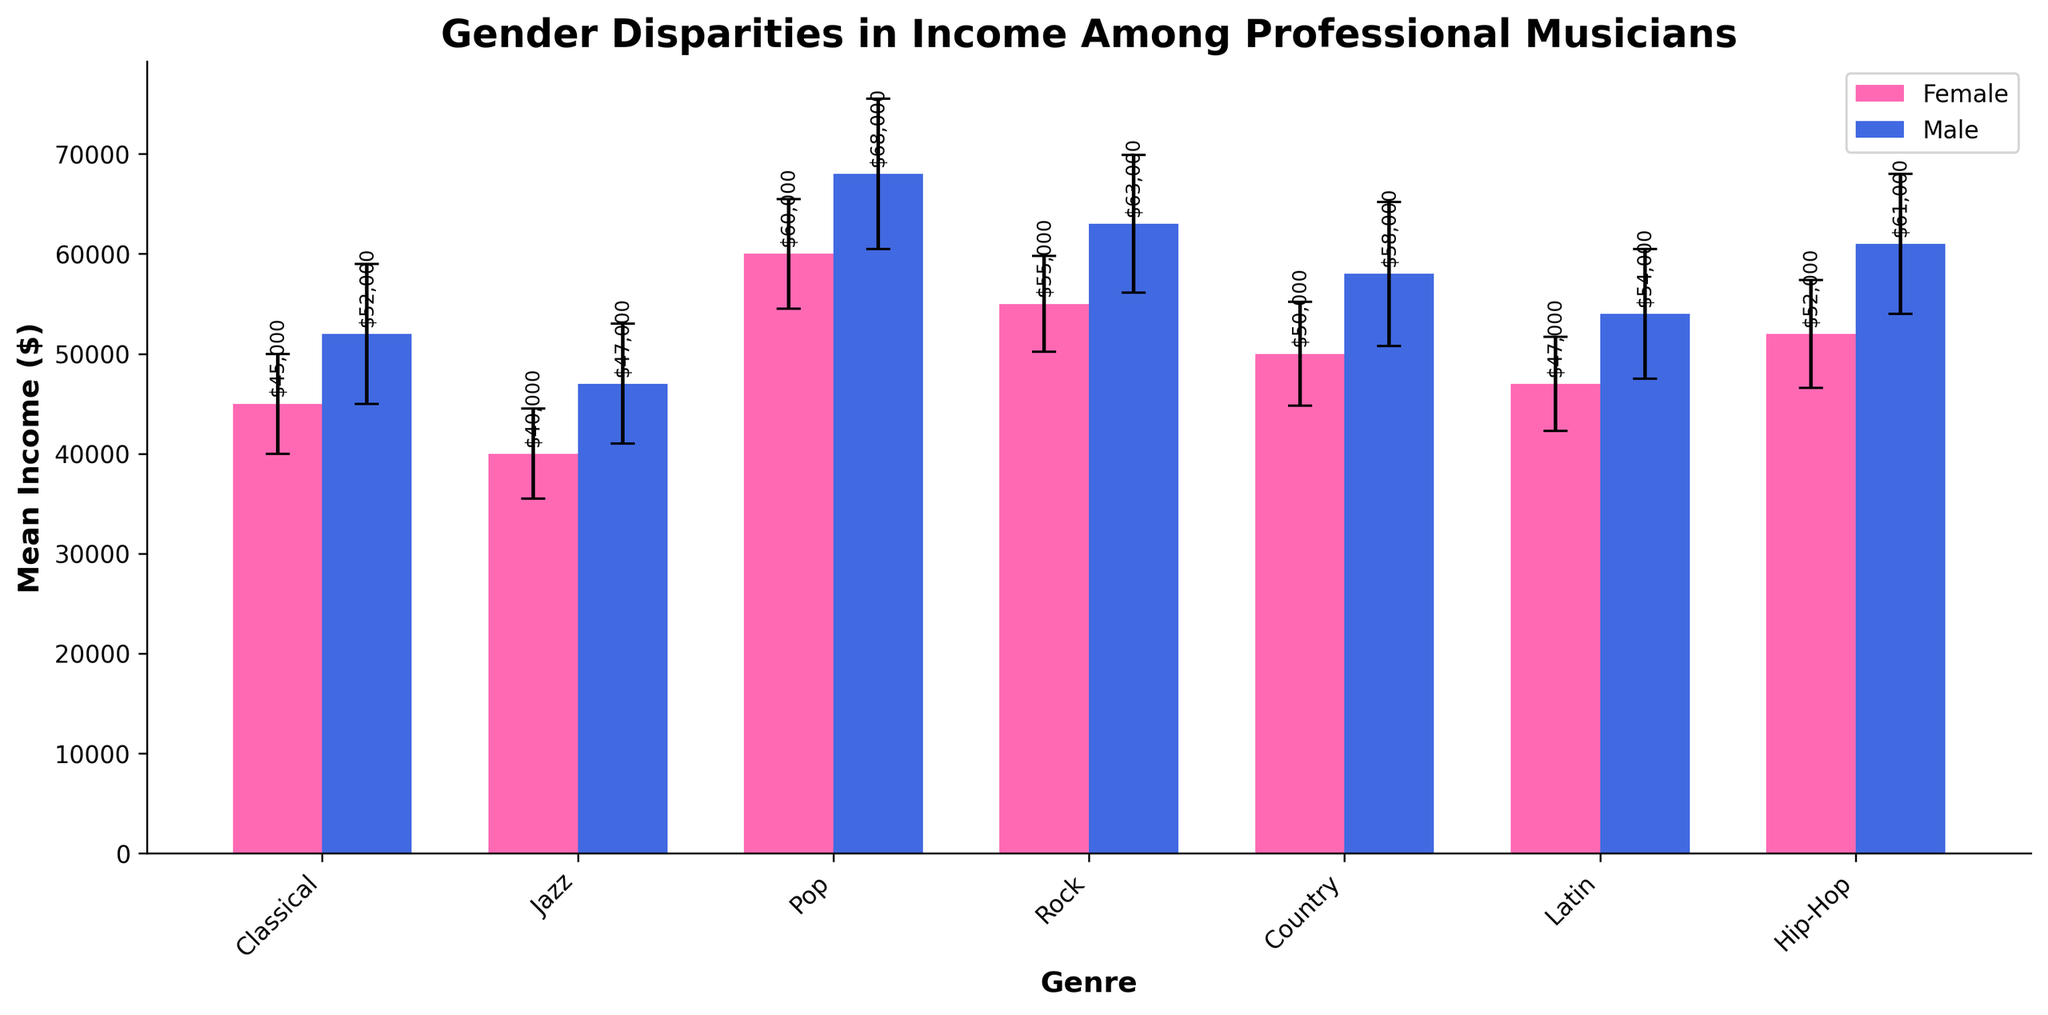What's the mean income for female musicians in the Classical genre? The figure shows the mean income for female musicians in the Classical genre as the height of the pink bar labeled "Classical" under "Female".
Answer: $45,000 What's the difference in mean income between male and female Jazz musicians? The mean income for male Jazz musicians is $47,000, and for female Jazz musicians, it is $40,000. The difference can be calculated by subtracting the mean income of female Jazz musicians from that of male Jazz musicians: $47,000 - $40,000
Answer: $7,000 Which genre shows the highest income disparity between male and female musicians? The income disparity can be found by comparing the differences in heights of the male and female bars for each genre. In the Pop genre, the male musicians have a mean income of $68,000, and female musicians have $60,000. The disparity is $68,000 - $60,000, which is $8,000. This is the highest among all genres.
Answer: Pop In which genre do female musicians earn more than male musicians? By visually examining the bars, we can see the bars for male musicians are higher in all genres compared to female musicians.
Answer: None What is the income standard deviation (STD) for female musicians in Hip-Hop? The figure includes error bars representing income standard deviation. For female musicians in Hip-Hop, the height of the error bar is labeled as $5,400.
Answer: $5,400 How much higher is the mean income of male Rock musicians compared to female Rock musicians? The mean income for male Rock musicians is $63,000, and for female Rock musicians, it is $55,000. The difference is $63,000 - $55,000
Answer: $8,000 How do the standard deviations of income compare between male and female Classical musicians? The standard deviation for female Classical musicians is $5,000, and for male Classical musicians, it is $7,000. Female Classical musicians have a smaller standard deviation compared to their male counterparts.
Answer: Male musicians have a higher standard deviation Which gender has greater variability in their mean income across all genres? Variability can be assessed by visually comparing the lengths of the error bars (standard deviations) across all genres. Generally, the error bars for male musicians are longer than those for female musicians.
Answer: Male What is the combined mean income of male musicians across the Hip-Hop and Latin genres? The mean income for male Hip-Hop musicians is $61,000, and for male Latin musicians, it is $54,000. Adding these together gives $61,000 + $54,000.
Answer: $115,000 Which genre shows the smallest gap between male and female musicians' incomes? By comparing the gaps visually, the Classical genre shows the smallest gap. The male musicians earn $52,000, and female musicians earn $45,000. The gap is $52,000 - $45,000
Answer: $7,000 